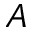Convert formula to latex. <formula><loc_0><loc_0><loc_500><loc_500>A</formula> 